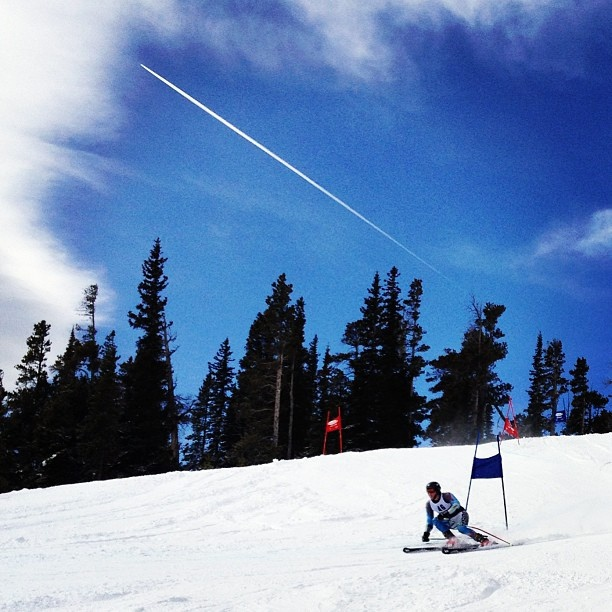Describe the objects in this image and their specific colors. I can see people in whitesmoke, black, navy, gray, and lavender tones and skis in whitesmoke, black, gray, and darkgray tones in this image. 